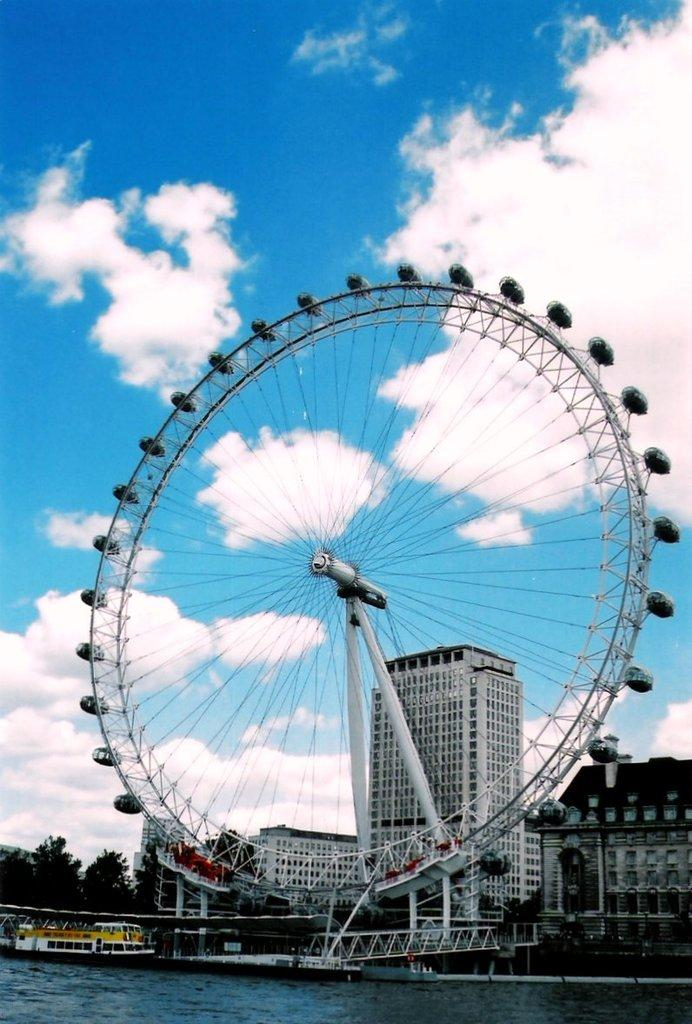What is the main feature in the image? There is a giant wheel in the image. What is located at the bottom of the image? There is water at the bottom of the image. What can be seen in the background of the image? There are buildings in the background of the image. What is visible in the sky at the top of the image? There are clouds in the sky at the top of the image. What type of paper is being used to build the giant wheel in the image? There is no paper present in the image, and the giant wheel is not being built; it is already constructed. 